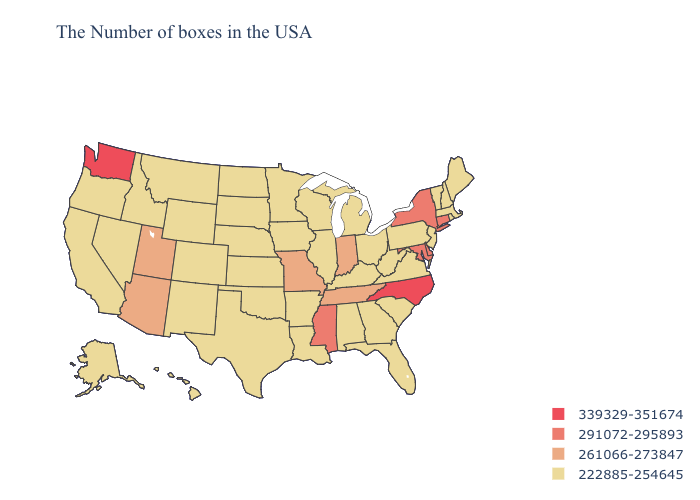Does Arkansas have a lower value than Nevada?
Write a very short answer. No. Which states hav the highest value in the MidWest?
Be succinct. Indiana, Missouri. Name the states that have a value in the range 291072-295893?
Short answer required. Connecticut, New York, Delaware, Maryland, Mississippi. Which states have the highest value in the USA?
Short answer required. North Carolina, Washington. Which states have the lowest value in the USA?
Write a very short answer. Maine, Massachusetts, Rhode Island, New Hampshire, Vermont, New Jersey, Pennsylvania, Virginia, South Carolina, West Virginia, Ohio, Florida, Georgia, Michigan, Kentucky, Alabama, Wisconsin, Illinois, Louisiana, Arkansas, Minnesota, Iowa, Kansas, Nebraska, Oklahoma, Texas, South Dakota, North Dakota, Wyoming, Colorado, New Mexico, Montana, Idaho, Nevada, California, Oregon, Alaska, Hawaii. What is the value of Rhode Island?
Concise answer only. 222885-254645. Name the states that have a value in the range 222885-254645?
Be succinct. Maine, Massachusetts, Rhode Island, New Hampshire, Vermont, New Jersey, Pennsylvania, Virginia, South Carolina, West Virginia, Ohio, Florida, Georgia, Michigan, Kentucky, Alabama, Wisconsin, Illinois, Louisiana, Arkansas, Minnesota, Iowa, Kansas, Nebraska, Oklahoma, Texas, South Dakota, North Dakota, Wyoming, Colorado, New Mexico, Montana, Idaho, Nevada, California, Oregon, Alaska, Hawaii. Which states have the lowest value in the USA?
Keep it brief. Maine, Massachusetts, Rhode Island, New Hampshire, Vermont, New Jersey, Pennsylvania, Virginia, South Carolina, West Virginia, Ohio, Florida, Georgia, Michigan, Kentucky, Alabama, Wisconsin, Illinois, Louisiana, Arkansas, Minnesota, Iowa, Kansas, Nebraska, Oklahoma, Texas, South Dakota, North Dakota, Wyoming, Colorado, New Mexico, Montana, Idaho, Nevada, California, Oregon, Alaska, Hawaii. Does Connecticut have the highest value in the USA?
Concise answer only. No. Which states have the highest value in the USA?
Keep it brief. North Carolina, Washington. Among the states that border Nevada , which have the lowest value?
Short answer required. Idaho, California, Oregon. Among the states that border Illinois , which have the highest value?
Write a very short answer. Indiana, Missouri. Does Arizona have a higher value than North Dakota?
Keep it brief. Yes. Name the states that have a value in the range 261066-273847?
Concise answer only. Indiana, Tennessee, Missouri, Utah, Arizona. 